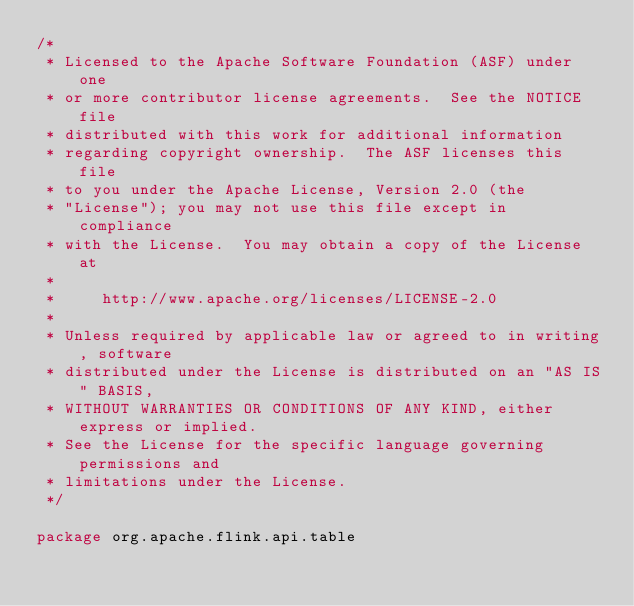Convert code to text. <code><loc_0><loc_0><loc_500><loc_500><_Scala_>/*
 * Licensed to the Apache Software Foundation (ASF) under one
 * or more contributor license agreements.  See the NOTICE file
 * distributed with this work for additional information
 * regarding copyright ownership.  The ASF licenses this file
 * to you under the Apache License, Version 2.0 (the
 * "License"); you may not use this file except in compliance
 * with the License.  You may obtain a copy of the License at
 *
 *     http://www.apache.org/licenses/LICENSE-2.0
 *
 * Unless required by applicable law or agreed to in writing, software
 * distributed under the License is distributed on an "AS IS" BASIS,
 * WITHOUT WARRANTIES OR CONDITIONS OF ANY KIND, either express or implied.
 * See the License for the specific language governing permissions and
 * limitations under the License.
 */

package org.apache.flink.api.table
</code> 